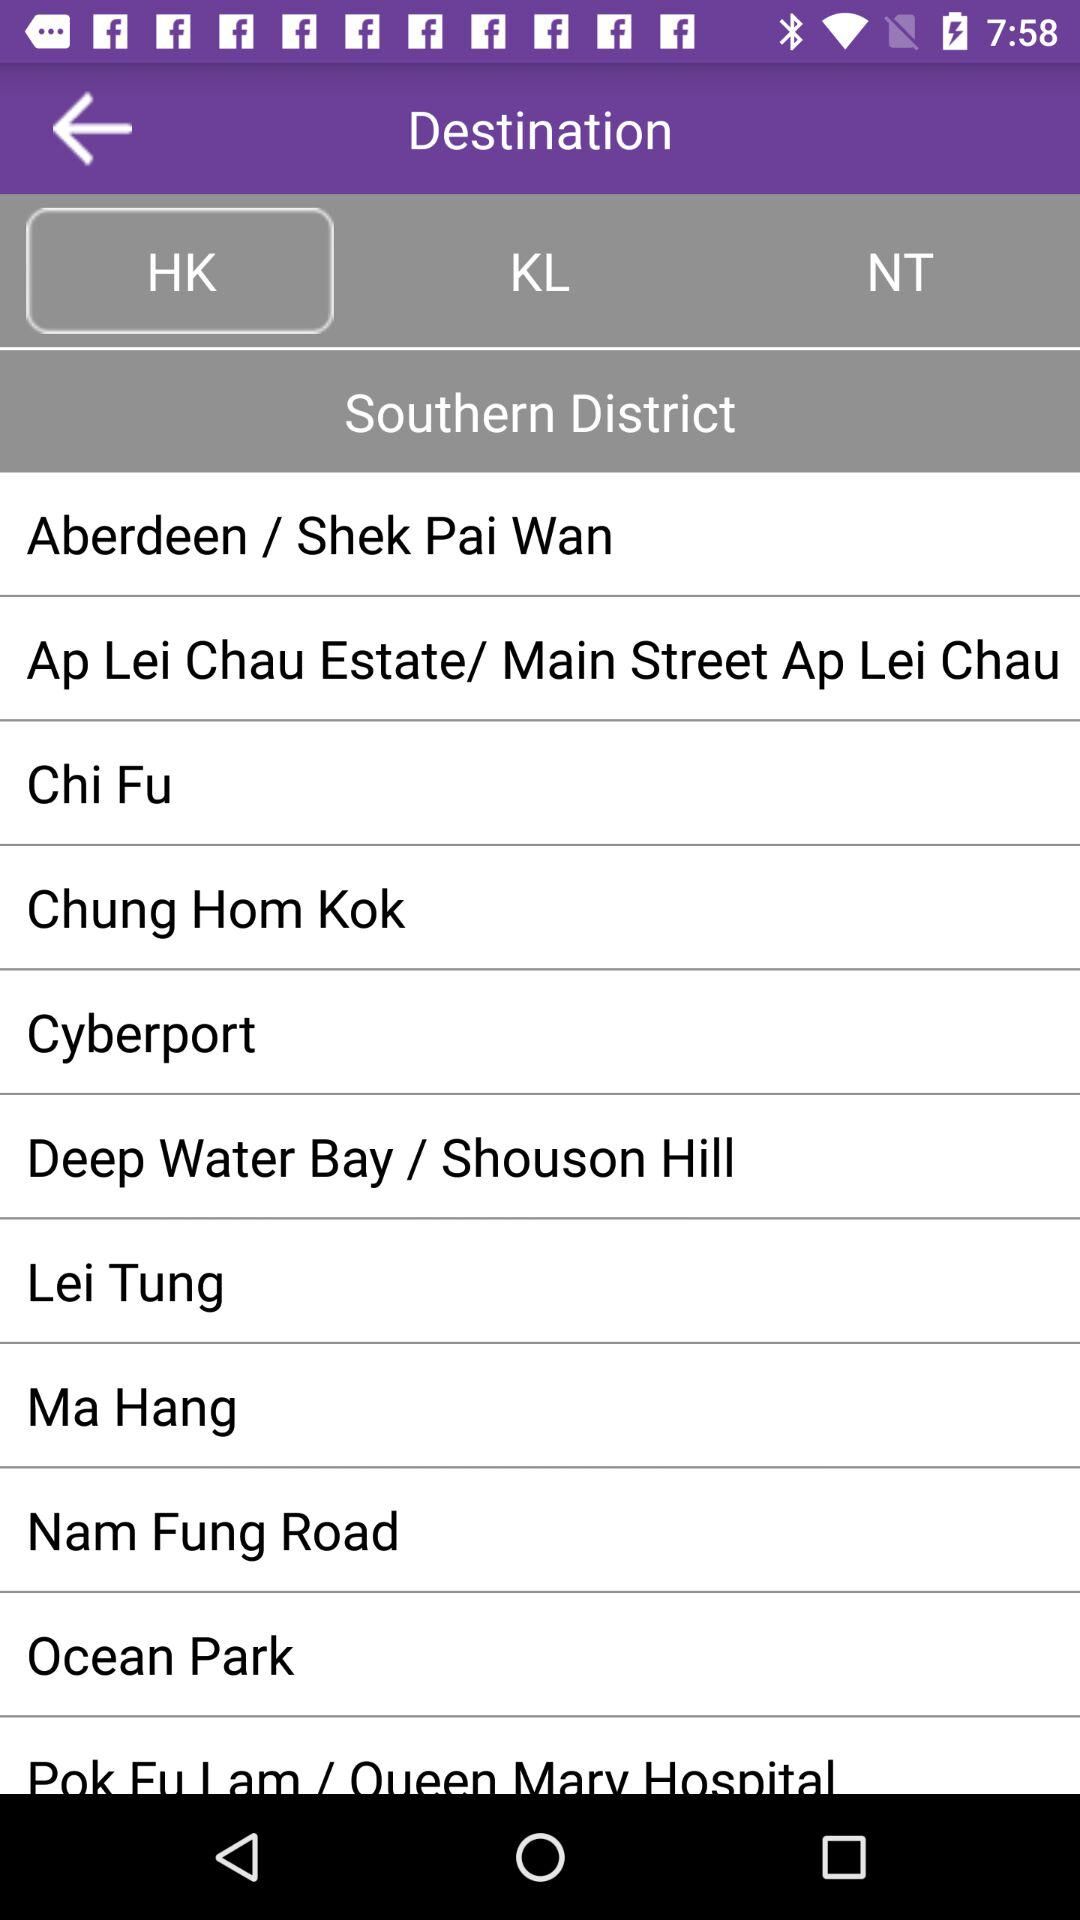Which tab of the application is selected? The selected tab is "HK". 